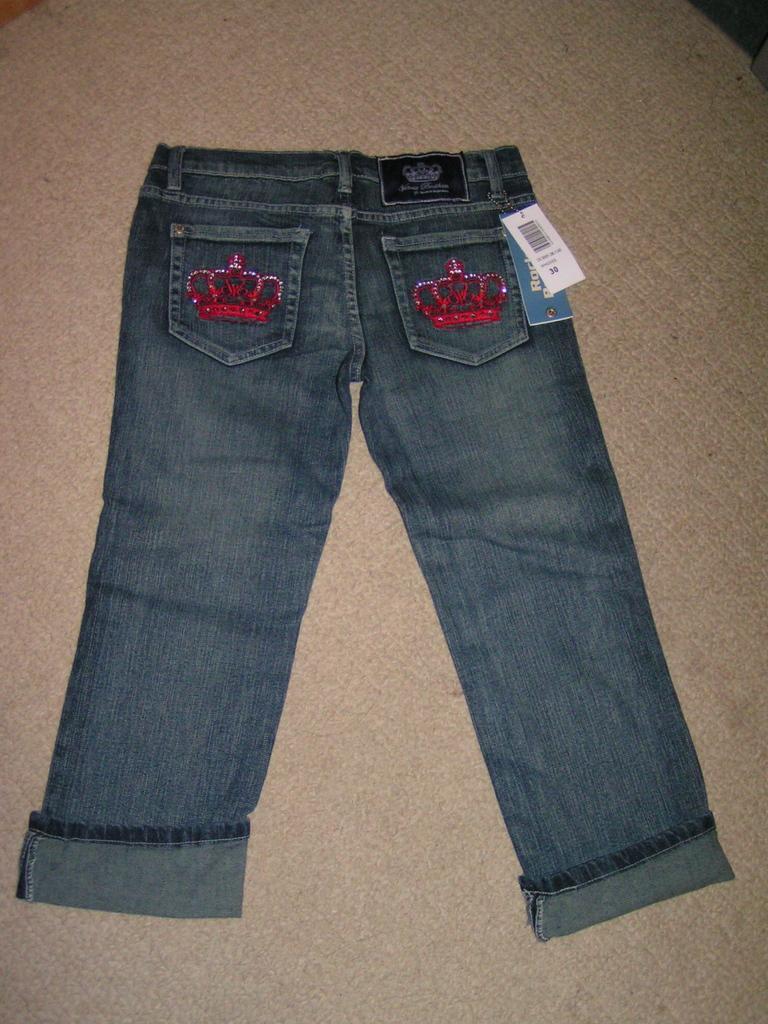Please provide a concise description of this image. In this image I can see a jeans and on the right side of the image I can see two paper tags. I can also see something is written on these tags. 